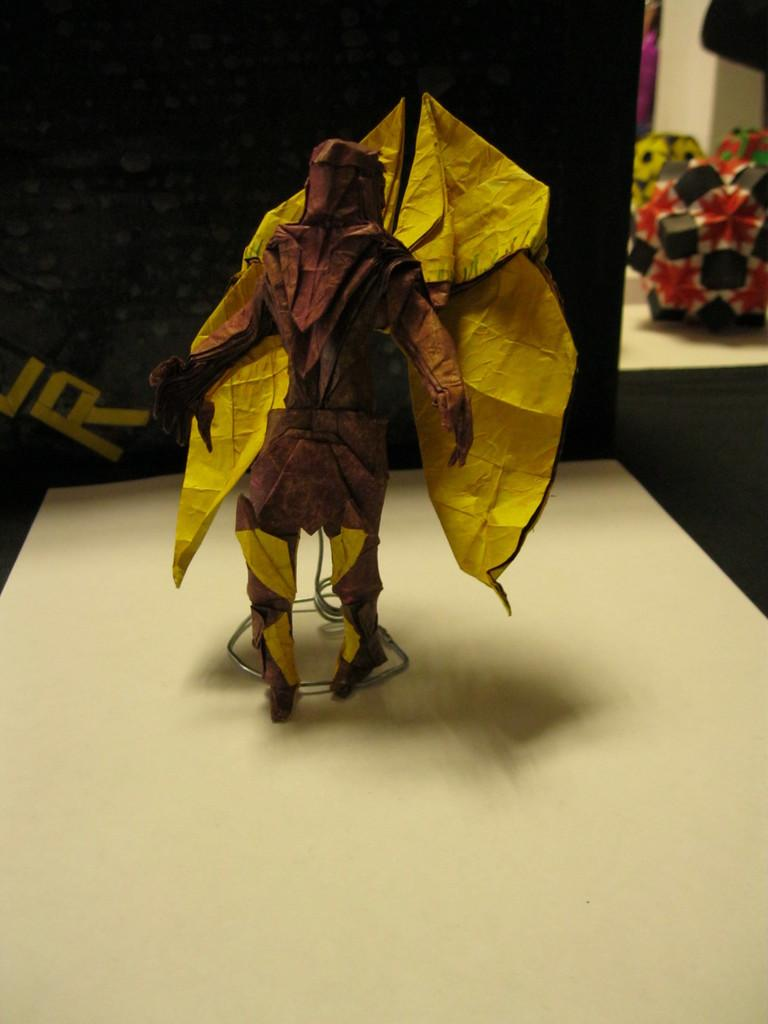What is the main subject on the table in the image? There is a mascot on the table in the image. What can be seen in the background of the image? There is a wall visible in the background of the image. Are there any other objects or features in the background of the image? Yes, there are objects present in the background of the image. What type of marble is being used to play a game in the image? There is no marble or game present in the image; it features a mascot on a table and a wall in the background. What advice does the grandmother give to the mascot in the image? There is no grandmother or interaction with the mascot in the image. 